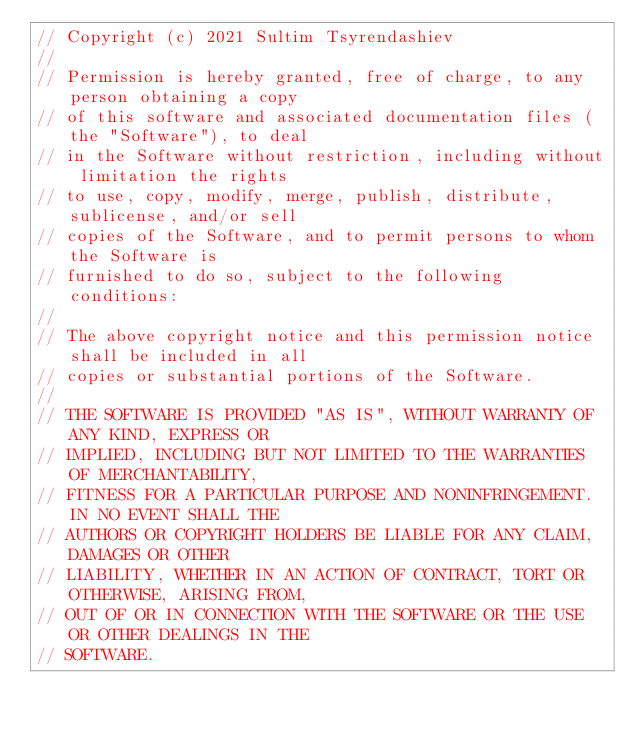Convert code to text. <code><loc_0><loc_0><loc_500><loc_500><_C_>// Copyright (c) 2021 Sultim Tsyrendashiev
// 
// Permission is hereby granted, free of charge, to any person obtaining a copy
// of this software and associated documentation files (the "Software"), to deal
// in the Software without restriction, including without limitation the rights
// to use, copy, modify, merge, publish, distribute, sublicense, and/or sell
// copies of the Software, and to permit persons to whom the Software is
// furnished to do so, subject to the following conditions:
// 
// The above copyright notice and this permission notice shall be included in all
// copies or substantial portions of the Software.
// 
// THE SOFTWARE IS PROVIDED "AS IS", WITHOUT WARRANTY OF ANY KIND, EXPRESS OR
// IMPLIED, INCLUDING BUT NOT LIMITED TO THE WARRANTIES OF MERCHANTABILITY,
// FITNESS FOR A PARTICULAR PURPOSE AND NONINFRINGEMENT. IN NO EVENT SHALL THE
// AUTHORS OR COPYRIGHT HOLDERS BE LIABLE FOR ANY CLAIM, DAMAGES OR OTHER
// LIABILITY, WHETHER IN AN ACTION OF CONTRACT, TORT OR OTHERWISE, ARISING FROM,
// OUT OF OR IN CONNECTION WITH THE SOFTWARE OR THE USE OR OTHER DEALINGS IN THE
// SOFTWARE.
</code> 